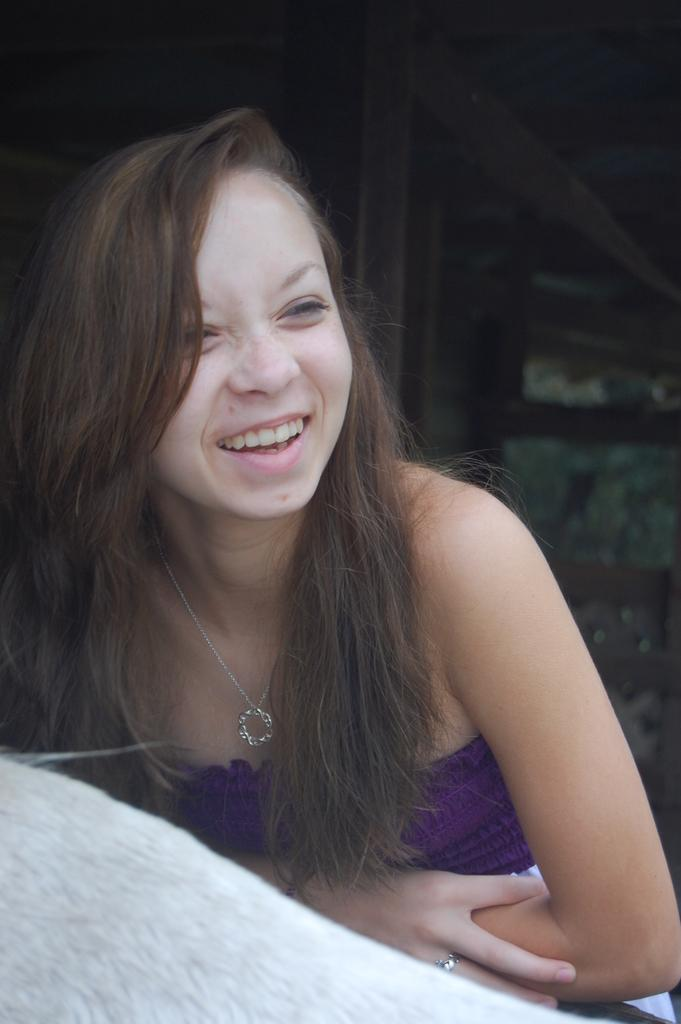Who is present in the image? There is a lady in the image. What expression does the lady have? The lady is smiling. What type of cheese is the lady holding in the image? There is no cheese present in the image; the lady is not holding anything. 